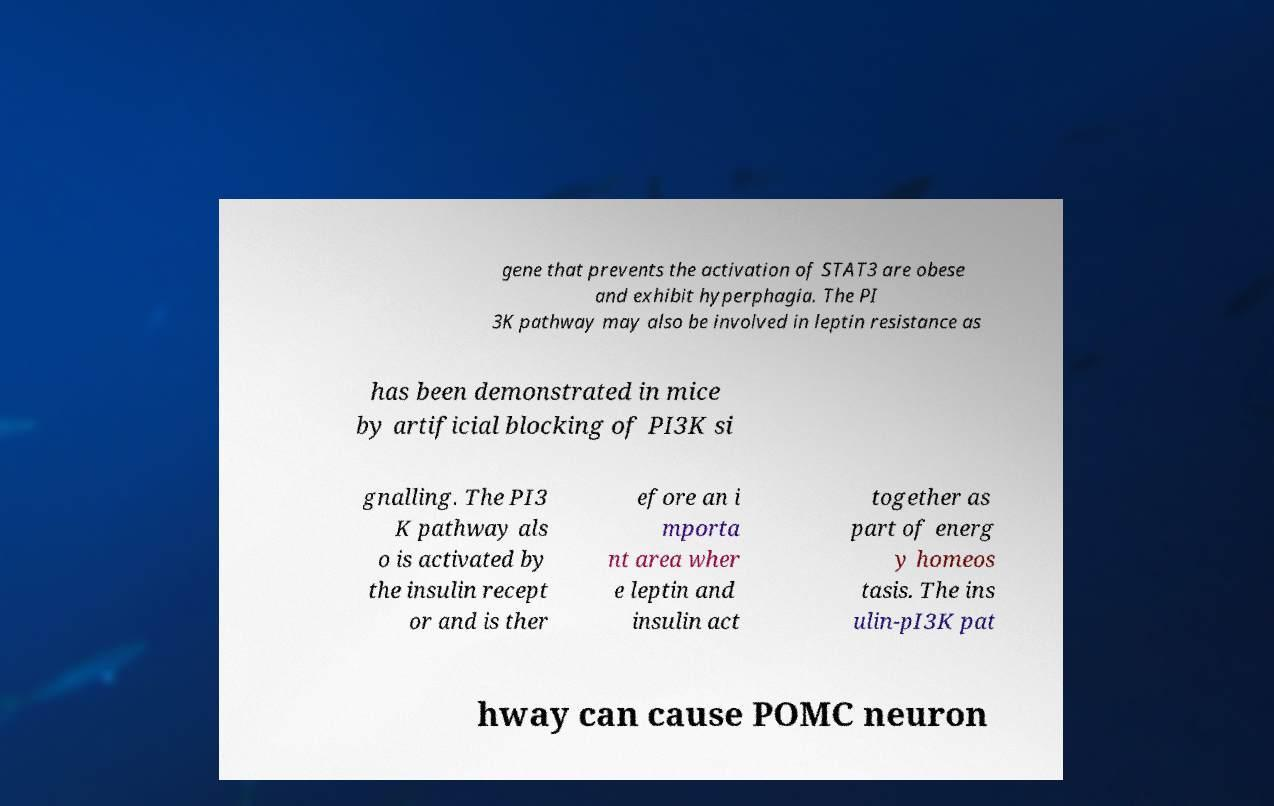Can you read and provide the text displayed in the image?This photo seems to have some interesting text. Can you extract and type it out for me? gene that prevents the activation of STAT3 are obese and exhibit hyperphagia. The PI 3K pathway may also be involved in leptin resistance as has been demonstrated in mice by artificial blocking of PI3K si gnalling. The PI3 K pathway als o is activated by the insulin recept or and is ther efore an i mporta nt area wher e leptin and insulin act together as part of energ y homeos tasis. The ins ulin-pI3K pat hway can cause POMC neuron 